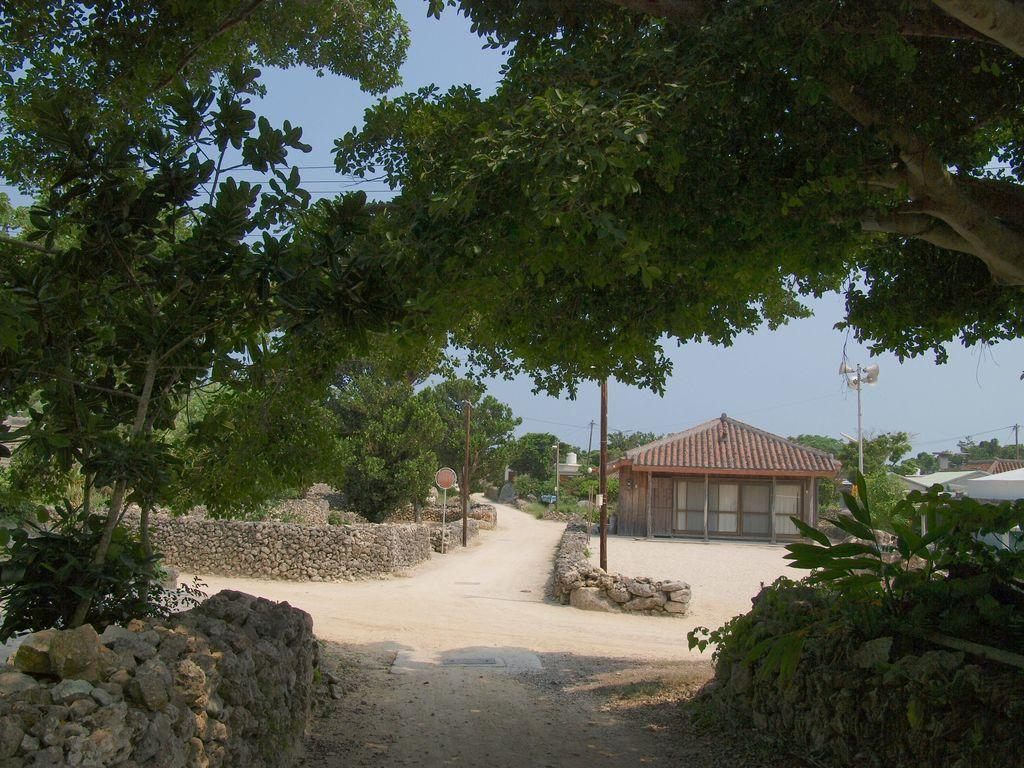What type of vegetation can be seen in the image? There are trees in the image. What is the color of the trees? The trees are green. What type of building is present in the image? There is a house in the image. What colors is the house? The house is gray and brown. What is attached to a pole in the image? There is a board attached to a pole in the image. What type of structure is present for illumination in the image? There is a light pole in the image. What is the color of the sky in the image? The sky is blue. Where is the playground located in the image? There is no playground present in the image. What type of laborer is working on the house in the image? There is no laborer present in the image, and the house is not under construction. 